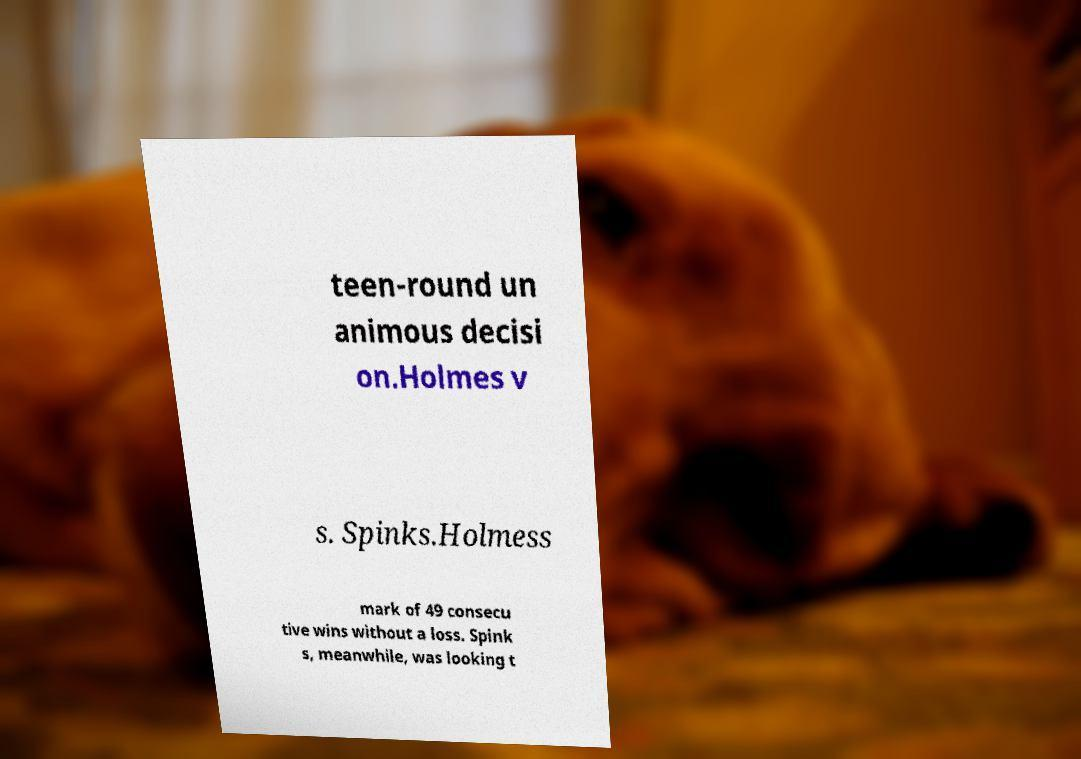For documentation purposes, I need the text within this image transcribed. Could you provide that? teen-round un animous decisi on.Holmes v s. Spinks.Holmess mark of 49 consecu tive wins without a loss. Spink s, meanwhile, was looking t 